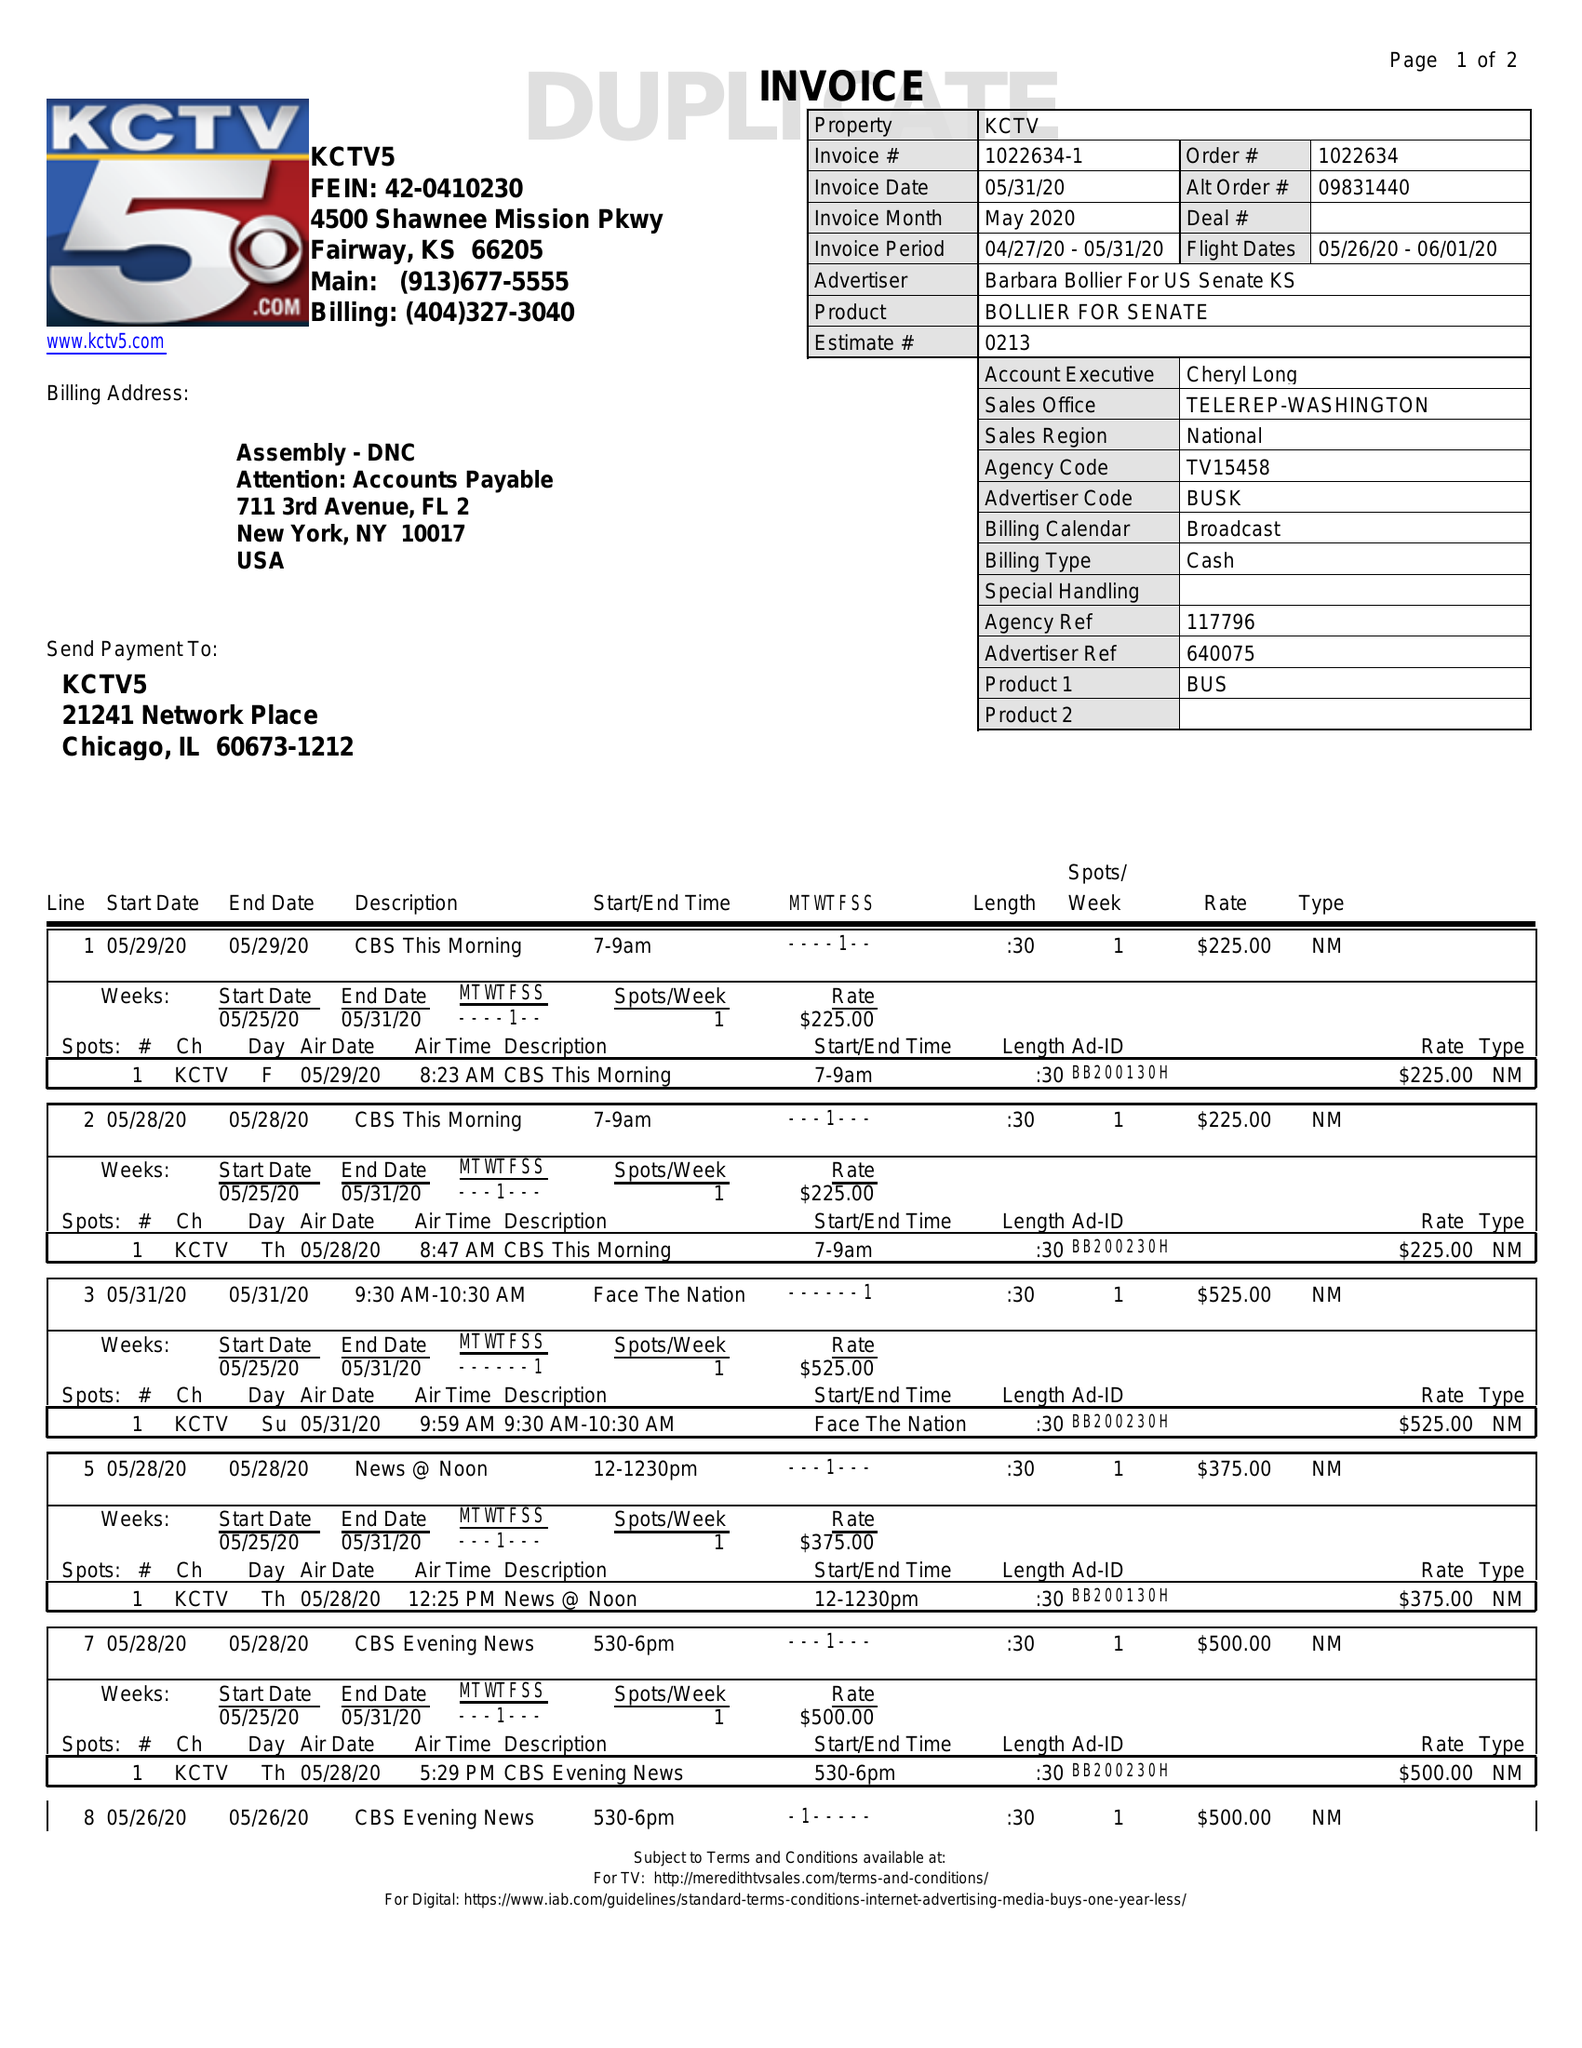What is the value for the gross_amount?
Answer the question using a single word or phrase. 3350.00 